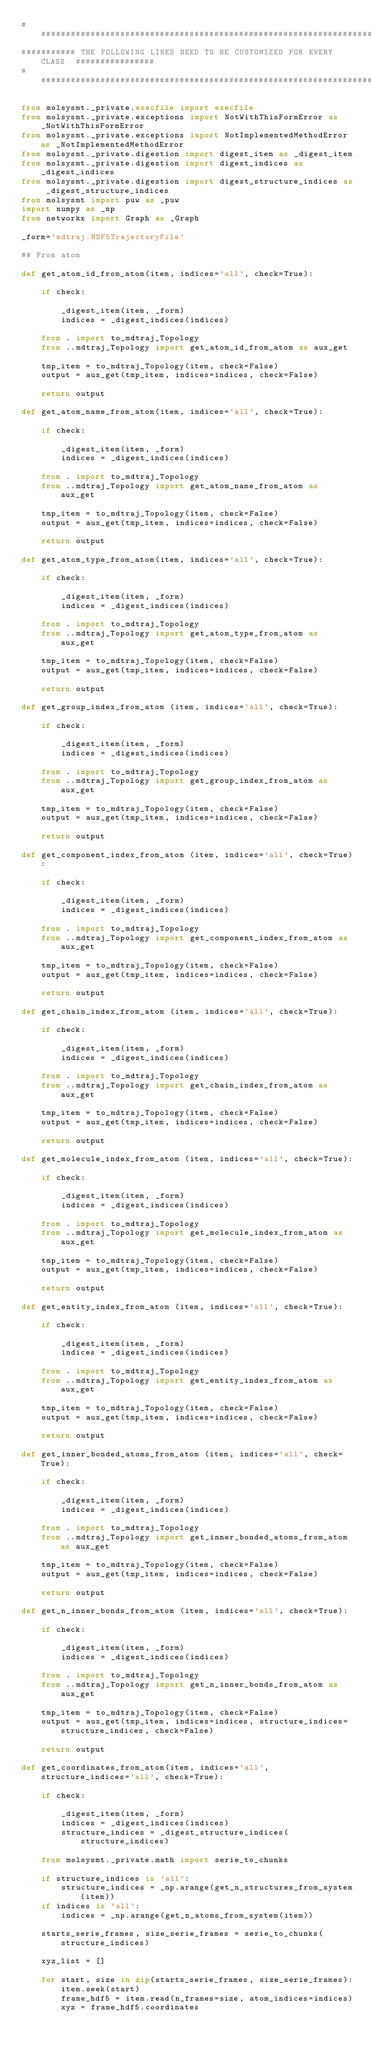<code> <loc_0><loc_0><loc_500><loc_500><_Python_>#######################################################################################
########### THE FOLLOWING LINES NEED TO BE CUSTOMIZED FOR EVERY CLASS  ################
#######################################################################################

from molsysmt._private.execfile import execfile
from molsysmt._private.exceptions import NotWithThisFormError as _NotWithThisFormError
from molsysmt._private.exceptions import NotImplementedMethodError as _NotImplementedMethodError
from molsysmt._private.digestion import digest_item as _digest_item
from molsysmt._private.digestion import digest_indices as _digest_indices
from molsysmt._private.digestion import digest_structure_indices as _digest_structure_indices
from molsysmt import puw as _puw
import numpy as _np
from networkx import Graph as _Graph

_form='mdtraj.HDF5TrajectoryFile'

## From atom

def get_atom_id_from_atom(item, indices='all', check=True):

    if check:

        _digest_item(item, _form)
        indices = _digest_indices(indices)

    from . import to_mdtraj_Topology
    from ..mdtraj_Topology import get_atom_id_from_atom as aux_get

    tmp_item = to_mdtraj_Topology(item, check=False)
    output = aux_get(tmp_item, indices=indices, check=False)

    return output

def get_atom_name_from_atom(item, indices='all', check=True):

    if check:

        _digest_item(item, _form)
        indices = _digest_indices(indices)

    from . import to_mdtraj_Topology
    from ..mdtraj_Topology import get_atom_name_from_atom as aux_get

    tmp_item = to_mdtraj_Topology(item, check=False)
    output = aux_get(tmp_item, indices=indices, check=False)

    return output

def get_atom_type_from_atom(item, indices='all', check=True):

    if check:

        _digest_item(item, _form)
        indices = _digest_indices(indices)

    from . import to_mdtraj_Topology
    from ..mdtraj_Topology import get_atom_type_from_atom as aux_get

    tmp_item = to_mdtraj_Topology(item, check=False)
    output = aux_get(tmp_item, indices=indices, check=False)

    return output

def get_group_index_from_atom (item, indices='all', check=True):

    if check:

        _digest_item(item, _form)
        indices = _digest_indices(indices)

    from . import to_mdtraj_Topology
    from ..mdtraj_Topology import get_group_index_from_atom as aux_get

    tmp_item = to_mdtraj_Topology(item, check=False)
    output = aux_get(tmp_item, indices=indices, check=False)

    return output

def get_component_index_from_atom (item, indices='all', check=True):

    if check:

        _digest_item(item, _form)
        indices = _digest_indices(indices)

    from . import to_mdtraj_Topology
    from ..mdtraj_Topology import get_component_index_from_atom as aux_get

    tmp_item = to_mdtraj_Topology(item, check=False)
    output = aux_get(tmp_item, indices=indices, check=False)

    return output

def get_chain_index_from_atom (item, indices='all', check=True):

    if check:

        _digest_item(item, _form)
        indices = _digest_indices(indices)

    from . import to_mdtraj_Topology
    from ..mdtraj_Topology import get_chain_index_from_atom as aux_get

    tmp_item = to_mdtraj_Topology(item, check=False)
    output = aux_get(tmp_item, indices=indices, check=False)

    return output

def get_molecule_index_from_atom (item, indices='all', check=True):

    if check:

        _digest_item(item, _form)
        indices = _digest_indices(indices)

    from . import to_mdtraj_Topology
    from ..mdtraj_Topology import get_molecule_index_from_atom as aux_get

    tmp_item = to_mdtraj_Topology(item, check=False)
    output = aux_get(tmp_item, indices=indices, check=False)

    return output

def get_entity_index_from_atom (item, indices='all', check=True):

    if check:

        _digest_item(item, _form)
        indices = _digest_indices(indices)

    from . import to_mdtraj_Topology
    from ..mdtraj_Topology import get_entity_index_from_atom as aux_get

    tmp_item = to_mdtraj_Topology(item, check=False)
    output = aux_get(tmp_item, indices=indices, check=False)

    return output

def get_inner_bonded_atoms_from_atom (item, indices='all', check=True):

    if check:

        _digest_item(item, _form)
        indices = _digest_indices(indices)

    from . import to_mdtraj_Topology
    from ..mdtraj_Topology import get_inner_bonded_atoms_from_atom as aux_get

    tmp_item = to_mdtraj_Topology(item, check=False)
    output = aux_get(tmp_item, indices=indices, check=False)

    return output

def get_n_inner_bonds_from_atom (item, indices='all', check=True):

    if check:

        _digest_item(item, _form)
        indices = _digest_indices(indices)

    from . import to_mdtraj_Topology
    from ..mdtraj_Topology import get_n_inner_bonds_from_atom as aux_get

    tmp_item = to_mdtraj_Topology(item, check=False)
    output = aux_get(tmp_item, indices=indices, structure_indices=structure_indices, check=False)

    return output

def get_coordinates_from_atom(item, indices='all', structure_indices='all', check=True):

    if check:

        _digest_item(item, _form)
        indices = _digest_indices(indices)
        structure_indices = _digest_structure_indices(structure_indices)

    from molsysmt._private.math import serie_to_chunks

    if structure_indices is 'all':
        structure_indices = _np.arange(get_n_structures_from_system(item))
    if indices is 'all':
        indices = _np.arange(get_n_atoms_from_system(item))

    starts_serie_frames, size_serie_frames = serie_to_chunks(structure_indices)

    xyz_list = []

    for start, size in zip(starts_serie_frames, size_serie_frames):
        item.seek(start)
        frame_hdf5 = item.read(n_frames=size, atom_indices=indices)
        xyz = frame_hdf5.coordinates</code> 